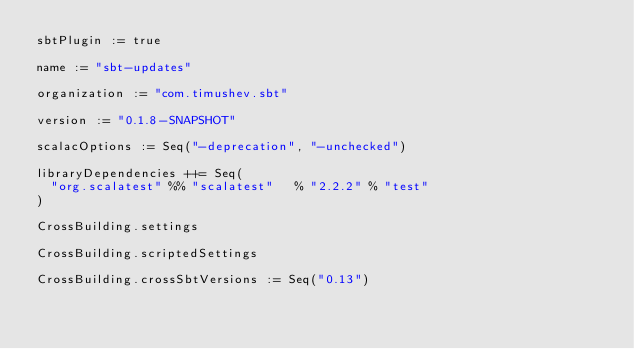<code> <loc_0><loc_0><loc_500><loc_500><_Scala_>sbtPlugin := true

name := "sbt-updates"

organization := "com.timushev.sbt"

version := "0.1.8-SNAPSHOT"

scalacOptions := Seq("-deprecation", "-unchecked")

libraryDependencies ++= Seq(
  "org.scalatest" %% "scalatest"   % "2.2.2" % "test"
)

CrossBuilding.settings

CrossBuilding.scriptedSettings

CrossBuilding.crossSbtVersions := Seq("0.13")

</code> 